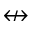Convert formula to latex. <formula><loc_0><loc_0><loc_500><loc_500>\ n l e f t r i g h t a r r o w</formula> 